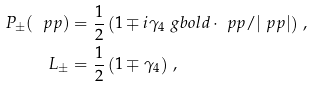Convert formula to latex. <formula><loc_0><loc_0><loc_500><loc_500>P _ { \pm } ( \ p p ) & = \frac { 1 } { 2 } \left ( 1 \mp i \gamma _ { 4 } \ g b o l d \cdot \ p p / | \ p p | \right ) \, , \\ L _ { \pm } & = \frac { 1 } { 2 } \left ( 1 \mp \gamma _ { 4 } \right ) \, ,</formula> 